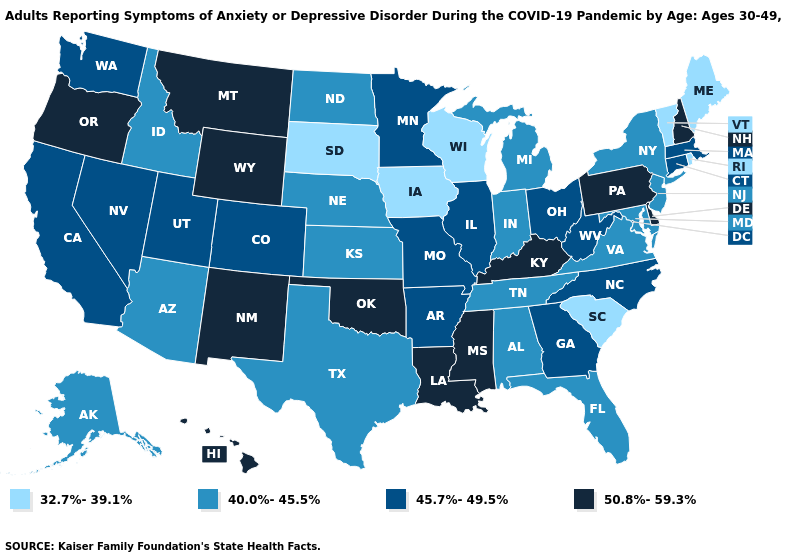Name the states that have a value in the range 45.7%-49.5%?
Short answer required. Arkansas, California, Colorado, Connecticut, Georgia, Illinois, Massachusetts, Minnesota, Missouri, Nevada, North Carolina, Ohio, Utah, Washington, West Virginia. Among the states that border Nevada , does Arizona have the lowest value?
Concise answer only. Yes. Does Massachusetts have a higher value than Hawaii?
Keep it brief. No. Does West Virginia have the highest value in the USA?
Short answer required. No. What is the lowest value in states that border Minnesota?
Write a very short answer. 32.7%-39.1%. Among the states that border West Virginia , does Maryland have the lowest value?
Give a very brief answer. Yes. Does Ohio have the lowest value in the USA?
Give a very brief answer. No. Name the states that have a value in the range 40.0%-45.5%?
Quick response, please. Alabama, Alaska, Arizona, Florida, Idaho, Indiana, Kansas, Maryland, Michigan, Nebraska, New Jersey, New York, North Dakota, Tennessee, Texas, Virginia. Name the states that have a value in the range 45.7%-49.5%?
Short answer required. Arkansas, California, Colorado, Connecticut, Georgia, Illinois, Massachusetts, Minnesota, Missouri, Nevada, North Carolina, Ohio, Utah, Washington, West Virginia. Name the states that have a value in the range 40.0%-45.5%?
Give a very brief answer. Alabama, Alaska, Arizona, Florida, Idaho, Indiana, Kansas, Maryland, Michigan, Nebraska, New Jersey, New York, North Dakota, Tennessee, Texas, Virginia. Does Texas have a lower value than Idaho?
Keep it brief. No. What is the highest value in states that border Texas?
Answer briefly. 50.8%-59.3%. Name the states that have a value in the range 50.8%-59.3%?
Quick response, please. Delaware, Hawaii, Kentucky, Louisiana, Mississippi, Montana, New Hampshire, New Mexico, Oklahoma, Oregon, Pennsylvania, Wyoming. Does Pennsylvania have the lowest value in the USA?
Answer briefly. No. 